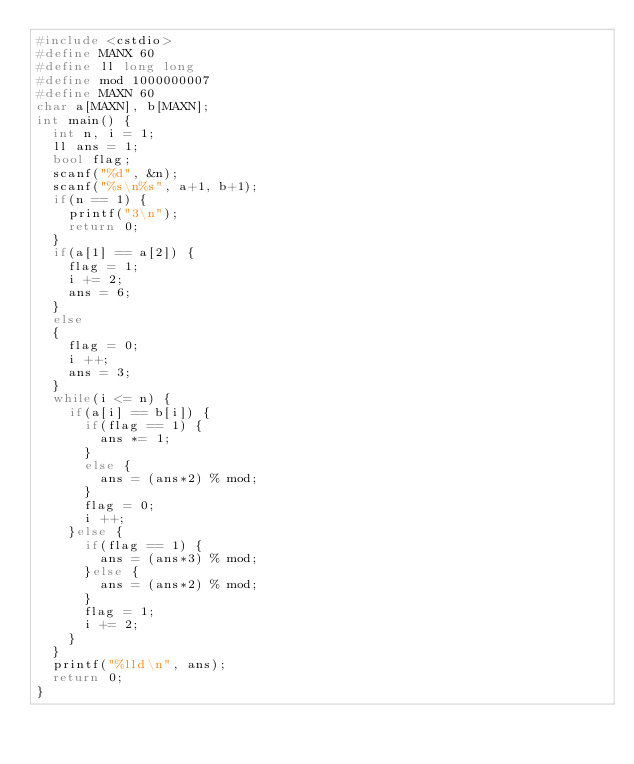<code> <loc_0><loc_0><loc_500><loc_500><_C++_>#include <cstdio>
#define MANX 60
#define ll long long
#define mod 1000000007
#define MAXN 60
char a[MAXN], b[MAXN];
int main() {
	int n, i = 1;
	ll ans = 1;
	bool flag; 
	scanf("%d", &n); 
	scanf("%s\n%s", a+1, b+1);
	if(n == 1) {
		printf("3\n");
		return 0;
	}	
	if(a[1] == a[2]) {
		flag = 1;
		i += 2;
		ans = 6;
	}
	else
	{
		flag = 0;
		i ++;
		ans = 3;
	}
	while(i <= n) {
		if(a[i] == b[i]) {
			if(flag == 1) {
				ans *= 1;
			} 
			else {
				ans = (ans*2) % mod;
			} 
			flag = 0; 
			i ++;
		}else { 
			if(flag == 1) {
				ans = (ans*3) % mod; 
			}else {
				ans = (ans*2) % mod;
			}
			flag = 1;
			i += 2;
		}
	}
	printf("%lld\n", ans);
	return 0;
}
</code> 